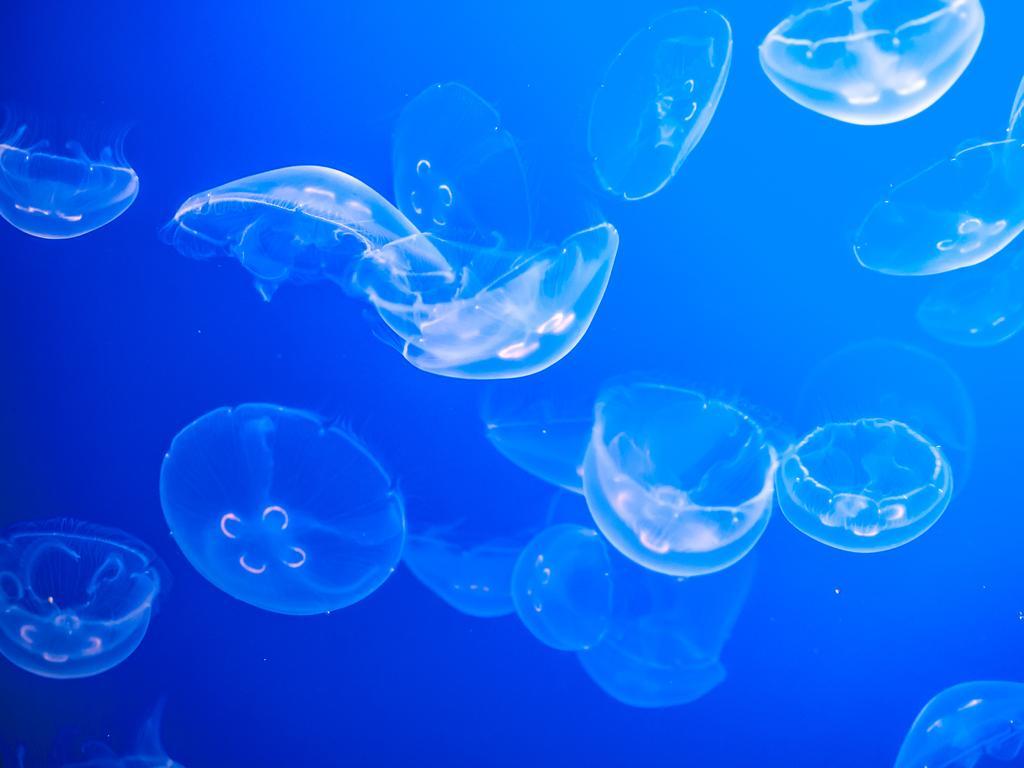How would you summarize this image in a sentence or two? In this picture we can see many Jellyfish under the water. 